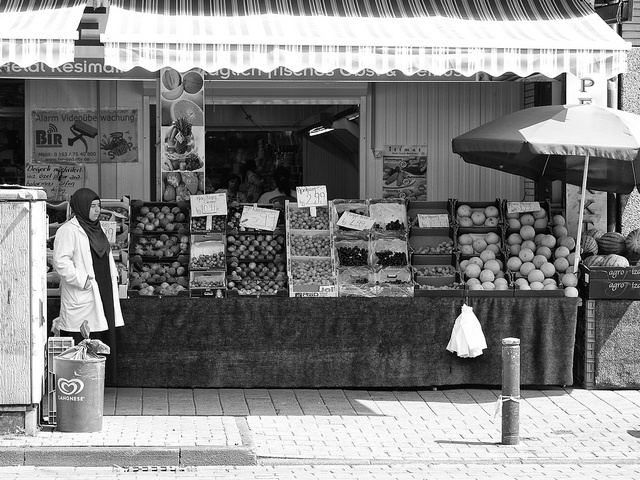Describe the objects in this image and their specific colors. I can see umbrella in gray, black, white, and darkgray tones, people in gray, lightgray, black, and darkgray tones, apple in gray and black tones, apple in gray and black tones, and apple in gray, black, darkgray, and lightgray tones in this image. 